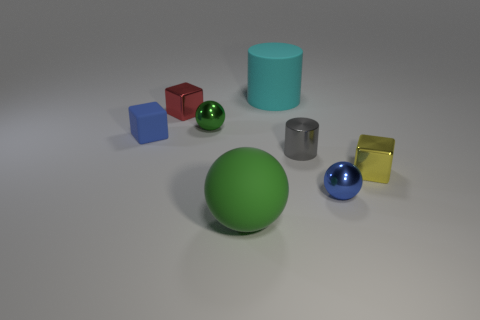What is the material of the big object in front of the tiny cube in front of the small blue object behind the yellow thing?
Give a very brief answer. Rubber. There is a small object that is the same color as the big rubber ball; what material is it?
Provide a succinct answer. Metal. Is the color of the tiny metal cube to the left of the tiny gray object the same as the big object in front of the yellow cube?
Give a very brief answer. No. The green thing in front of the blue thing on the right side of the green thing to the left of the big green matte ball is what shape?
Your response must be concise. Sphere. There is a tiny shiny object that is both to the left of the small blue metallic ball and on the right side of the big rubber cylinder; what shape is it?
Provide a succinct answer. Cylinder. There is a big thing that is right of the matte thing that is in front of the small blue matte object; how many tiny blue matte things are behind it?
Offer a terse response. 0. There is another thing that is the same shape as the small gray shiny thing; what size is it?
Provide a short and direct response. Large. Is there any other thing that is the same size as the cyan matte thing?
Provide a succinct answer. Yes. Is the blue object to the right of the small cylinder made of the same material as the small gray cylinder?
Your answer should be very brief. Yes. What color is the matte thing that is the same shape as the red metal thing?
Your answer should be very brief. Blue. 